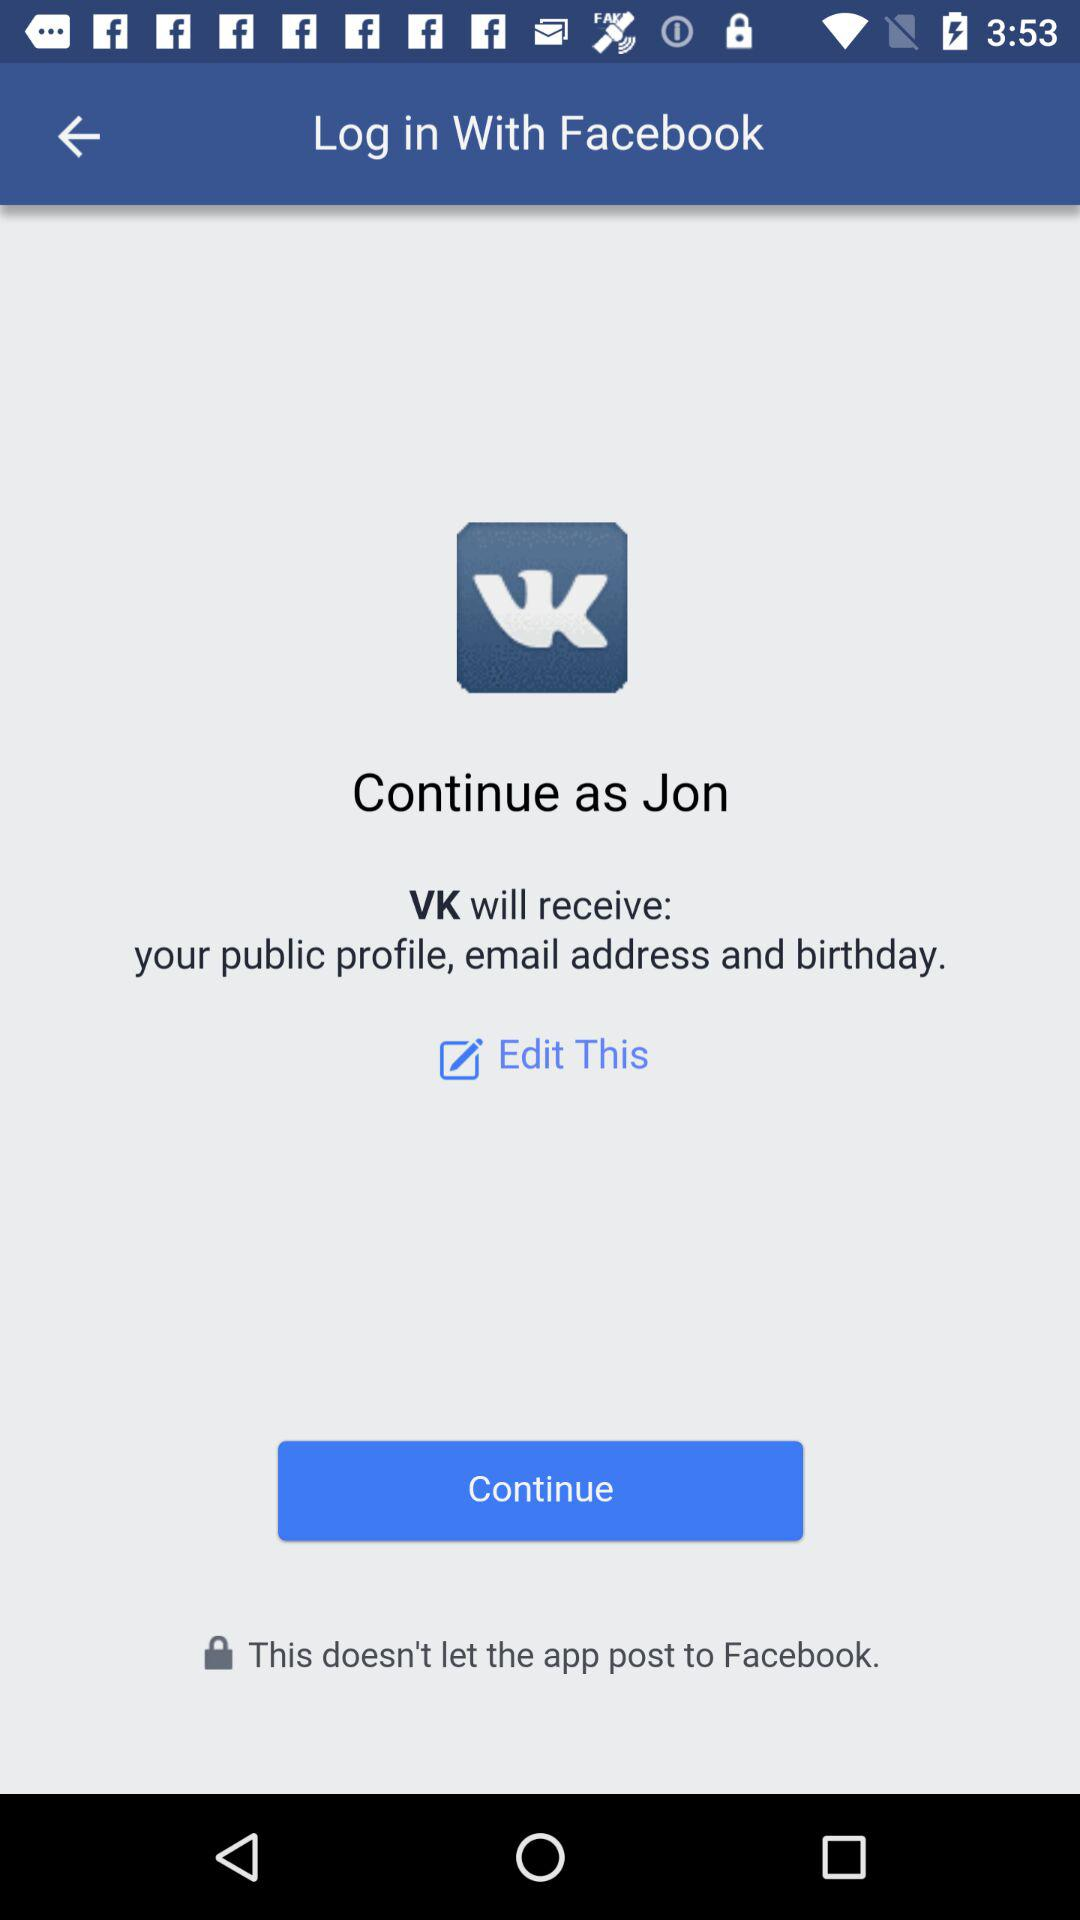What information will VK receive? VK will receive your public profile, email address and birthday. 